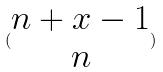<formula> <loc_0><loc_0><loc_500><loc_500>( \begin{matrix} n + x - 1 \\ n \end{matrix} )</formula> 